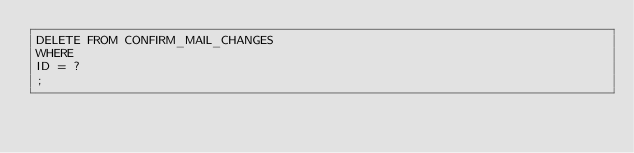Convert code to text. <code><loc_0><loc_0><loc_500><loc_500><_SQL_>DELETE FROM CONFIRM_MAIL_CHANGES
WHERE 
ID = ?
;
</code> 